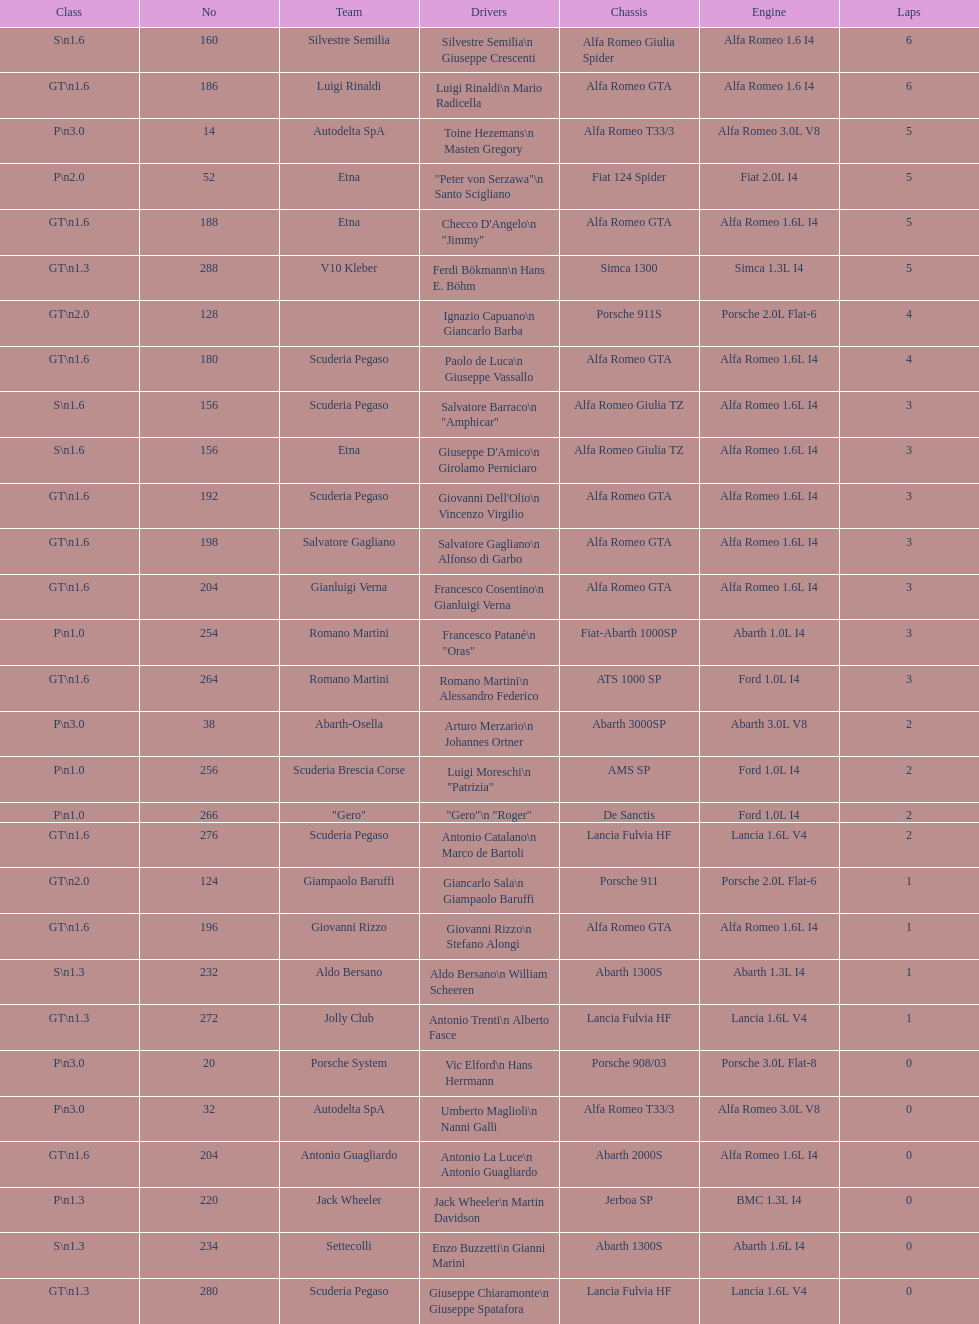What class is below s 1.6? GT 1.6. 